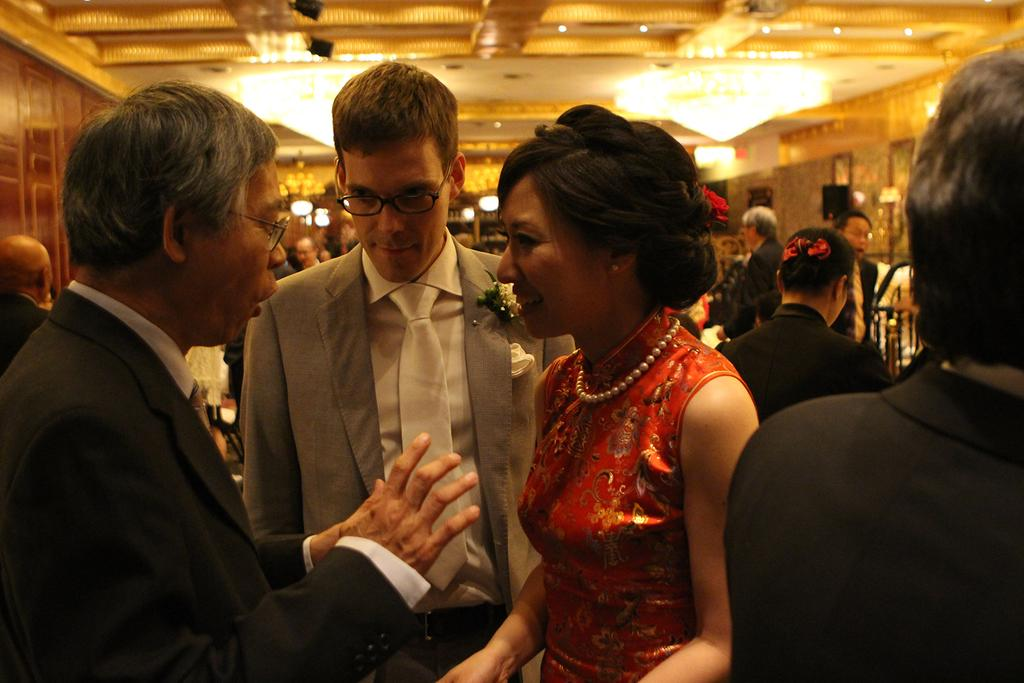What is located in the foreground of the image? There are people in the foreground of the image. What can be seen in the background of the image? There are chandeliers and people in the background of the image. What architectural feature is visible in the background of the image? There is a roof visible in the background of the image. What type of religious print can be seen hanging on the roof in the image? There is no religious print visible in the image; the roof is the only architectural feature mentioned. 